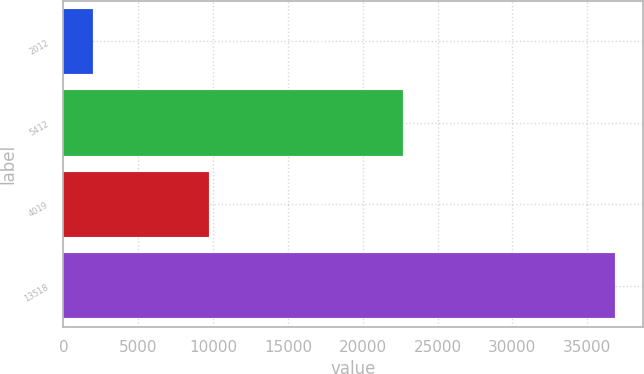Convert chart to OTSL. <chart><loc_0><loc_0><loc_500><loc_500><bar_chart><fcel>2012<fcel>5412<fcel>4019<fcel>13518<nl><fcel>2011<fcel>22683<fcel>9702<fcel>36875<nl></chart> 